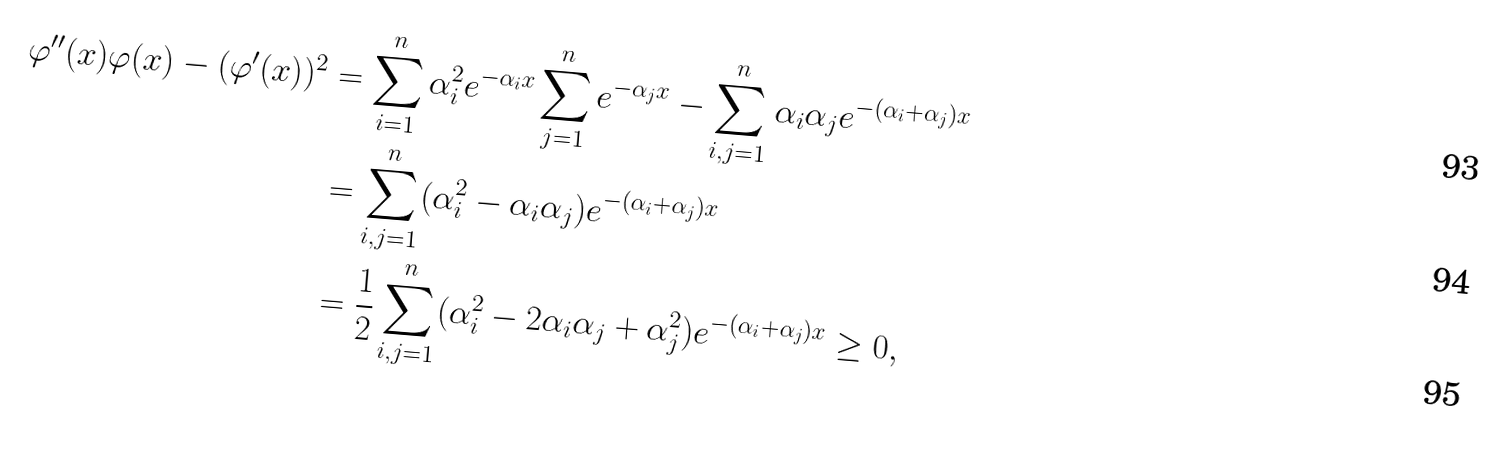Convert formula to latex. <formula><loc_0><loc_0><loc_500><loc_500>\varphi ^ { \prime \prime } ( x ) \varphi ( x ) - ( \varphi ^ { \prime } ( x ) ) ^ { 2 } & = \sum _ { i = 1 } ^ { n } \alpha _ { i } ^ { 2 } e ^ { - \alpha _ { i } x } \sum _ { j = 1 } ^ { n } e ^ { - \alpha _ { j } x } - \sum _ { i , j = 1 } ^ { n } \alpha _ { i } \alpha _ { j } e ^ { - ( \alpha _ { i } + \alpha _ { j } ) x } \\ & = \sum _ { i , j = 1 } ^ { n } ( \alpha _ { i } ^ { 2 } - \alpha _ { i } \alpha _ { j } ) e ^ { - ( \alpha _ { i } + \alpha _ { j } ) x } \\ & = \frac { 1 } { 2 } \sum _ { i , j = 1 } ^ { n } ( \alpha _ { i } ^ { 2 } - 2 \alpha _ { i } \alpha _ { j } + \alpha _ { j } ^ { 2 } ) e ^ { - ( \alpha _ { i } + \alpha _ { j } ) x } \geq 0 ,</formula> 